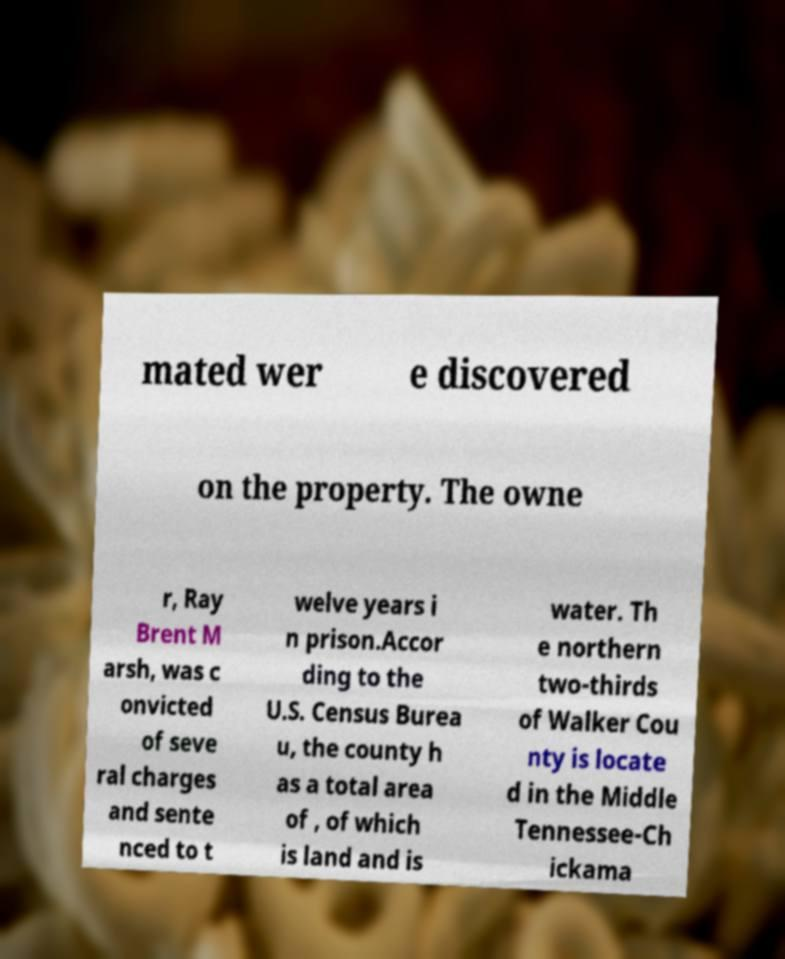Please identify and transcribe the text found in this image. mated wer e discovered on the property. The owne r, Ray Brent M arsh, was c onvicted of seve ral charges and sente nced to t welve years i n prison.Accor ding to the U.S. Census Burea u, the county h as a total area of , of which is land and is water. Th e northern two-thirds of Walker Cou nty is locate d in the Middle Tennessee-Ch ickama 